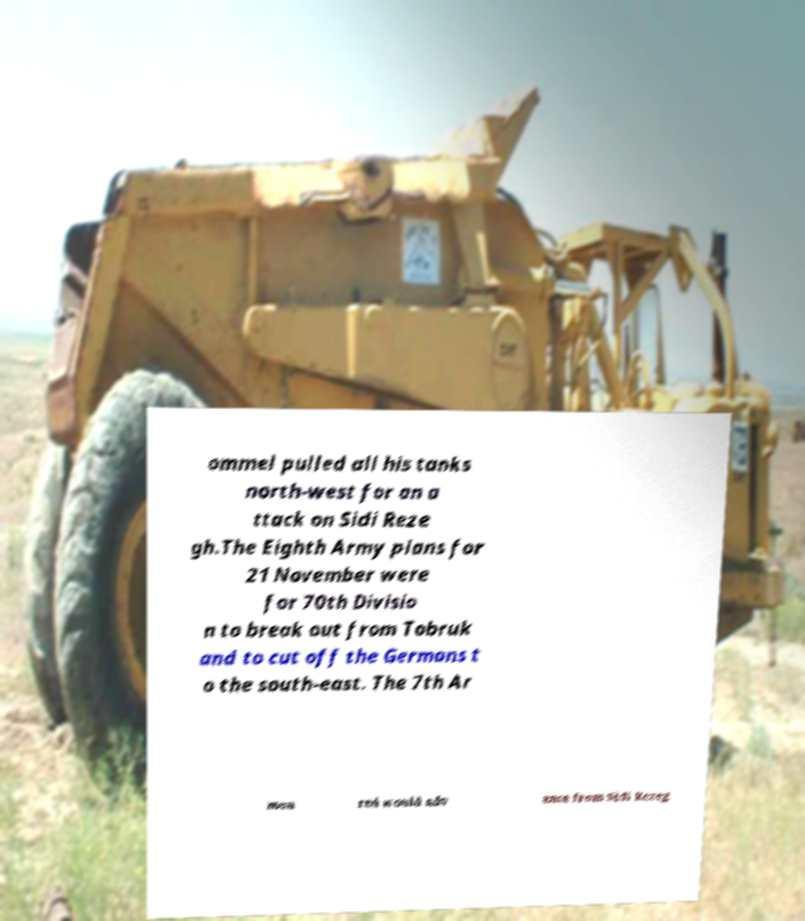There's text embedded in this image that I need extracted. Can you transcribe it verbatim? ommel pulled all his tanks north-west for an a ttack on Sidi Reze gh.The Eighth Army plans for 21 November were for 70th Divisio n to break out from Tobruk and to cut off the Germans t o the south-east. The 7th Ar mou red would adv ance from Sidi Rezeg 